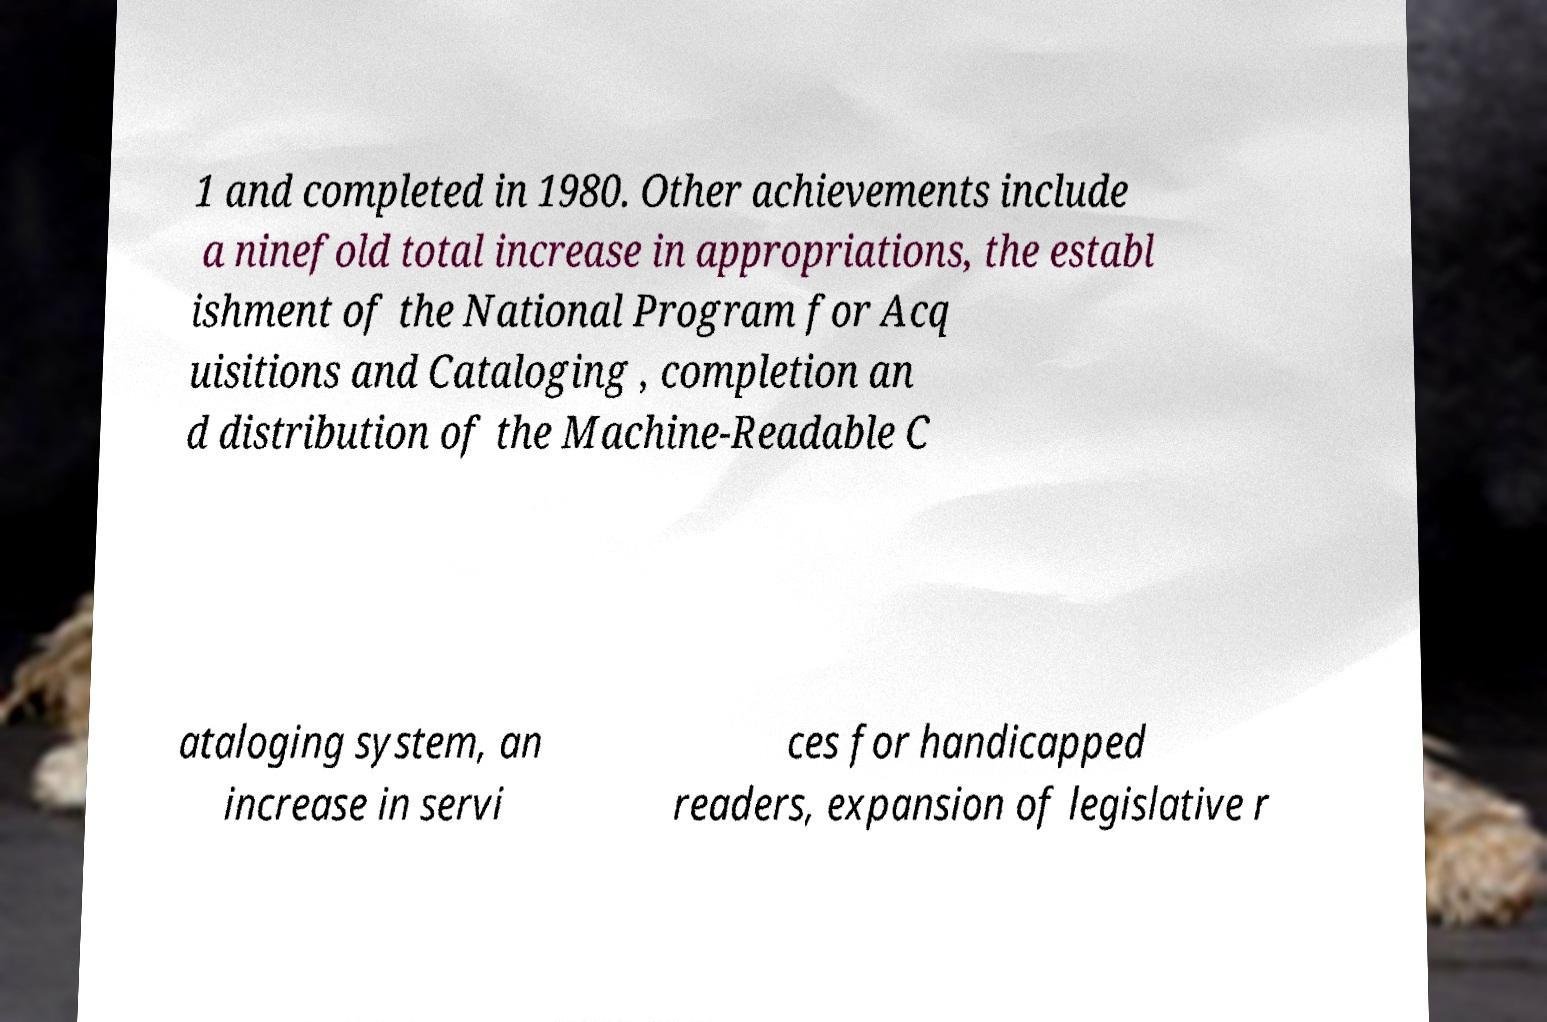What messages or text are displayed in this image? I need them in a readable, typed format. 1 and completed in 1980. Other achievements include a ninefold total increase in appropriations, the establ ishment of the National Program for Acq uisitions and Cataloging , completion an d distribution of the Machine-Readable C ataloging system, an increase in servi ces for handicapped readers, expansion of legislative r 